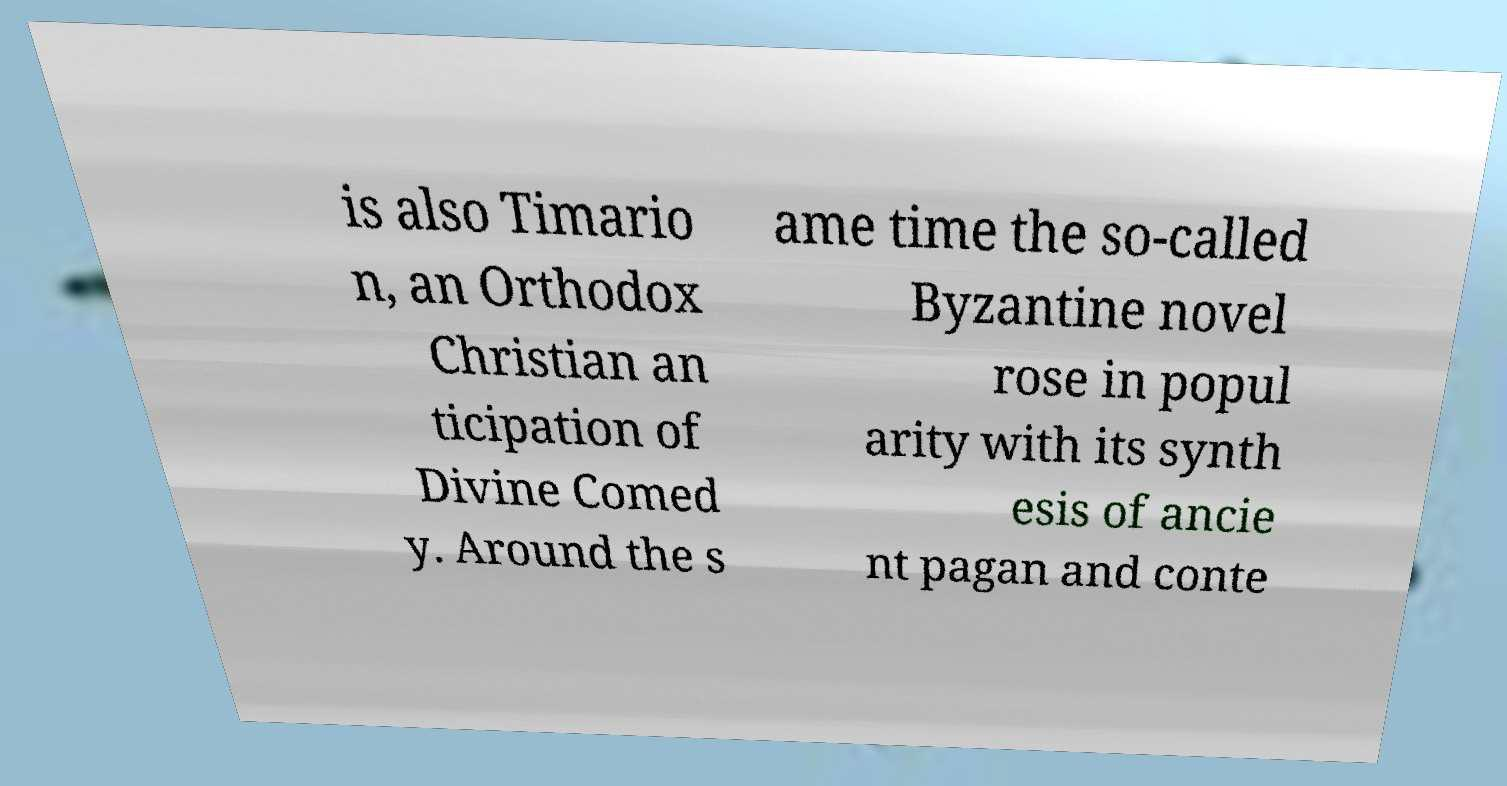Please identify and transcribe the text found in this image. is also Timario n, an Orthodox Christian an ticipation of Divine Comed y. Around the s ame time the so-called Byzantine novel rose in popul arity with its synth esis of ancie nt pagan and conte 